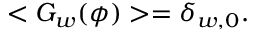Convert formula to latex. <formula><loc_0><loc_0><loc_500><loc_500>< G _ { w } ( \phi ) > = \delta _ { w , 0 } .</formula> 